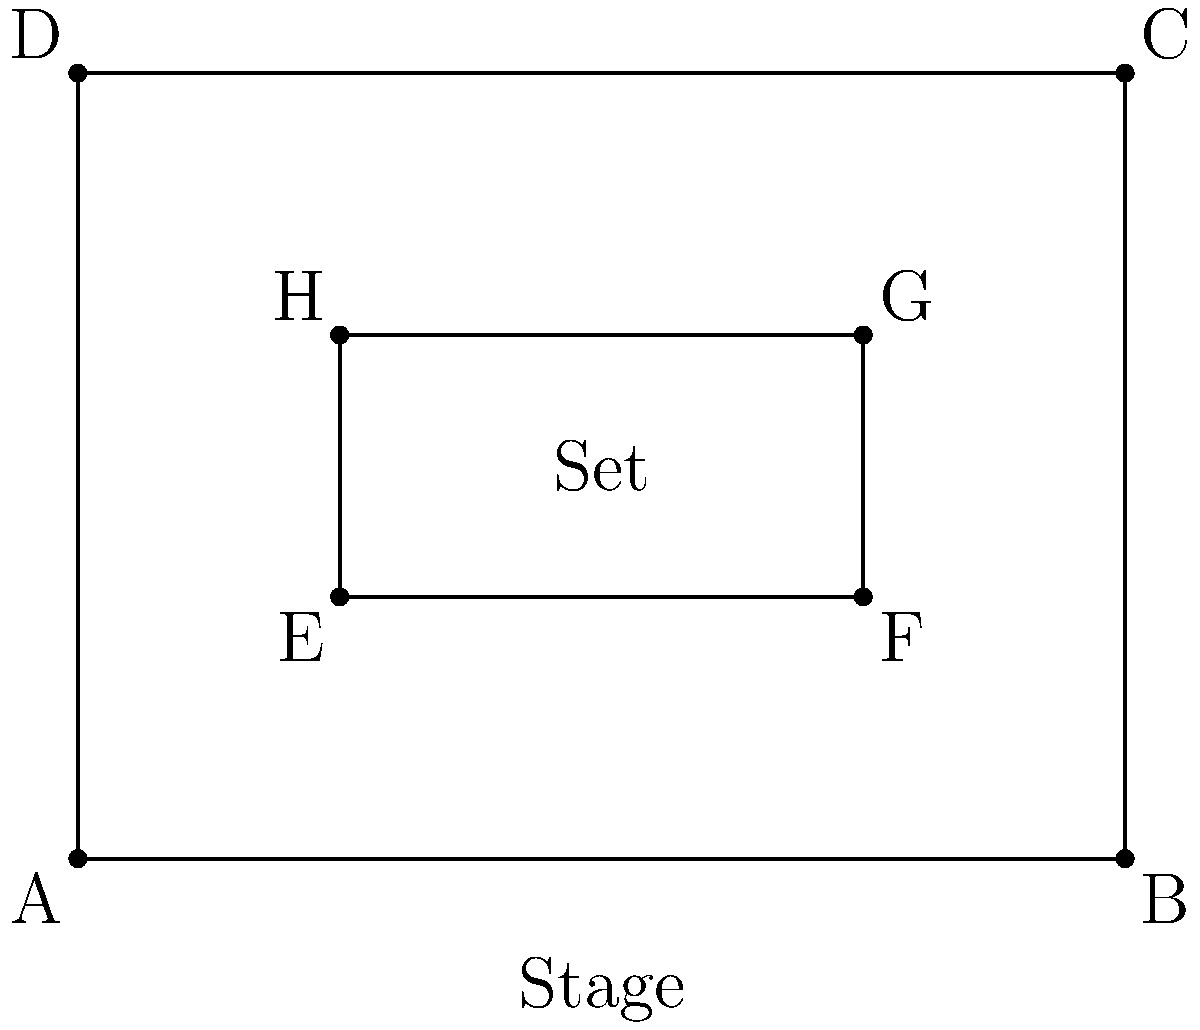In the stage layout shown, a rectangular set (EFGH) is placed within a larger rectangular stage (ABCD). How many lines of symmetry does the entire configuration have? To determine the number of lines of symmetry in this stage layout, we need to consider the symmetry of both the outer stage and the inner set:

1. Analyze the outer stage (ABCD):
   - It has 2 lines of symmetry: vertical and horizontal.

2. Analyze the inner set (EFGH):
   - It also has 2 lines of symmetry: vertical and horizontal.

3. Check if the inner set is centered within the outer stage:
   - The inner rectangle appears to be centered both vertically and horizontally.

4. Determine shared lines of symmetry:
   - Since both rectangles are centered and share the same shape (rectangles), they share both lines of symmetry.

5. Count the total lines of symmetry:
   - Vertical line through the center of both rectangles
   - Horizontal line through the center of both rectangles

Therefore, the entire configuration has 2 lines of symmetry.
Answer: 2 